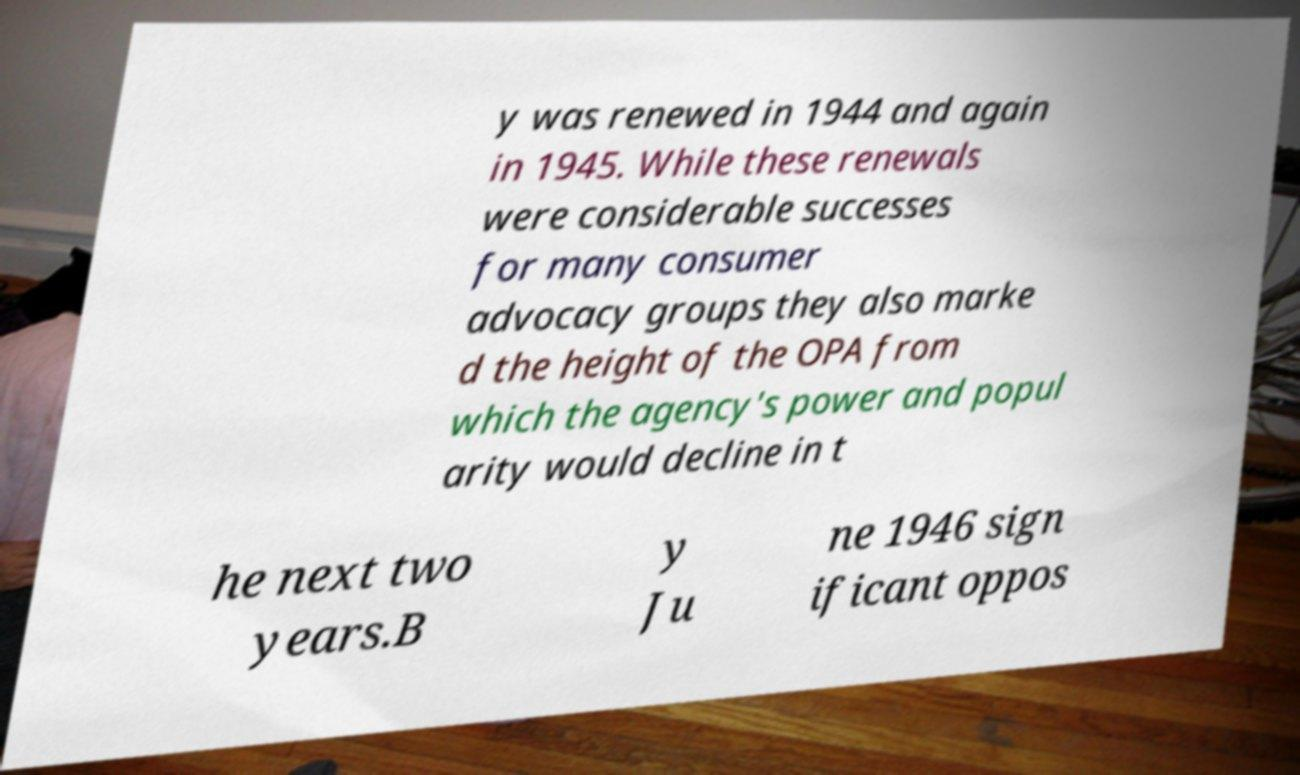Can you read and provide the text displayed in the image?This photo seems to have some interesting text. Can you extract and type it out for me? y was renewed in 1944 and again in 1945. While these renewals were considerable successes for many consumer advocacy groups they also marke d the height of the OPA from which the agency's power and popul arity would decline in t he next two years.B y Ju ne 1946 sign ificant oppos 